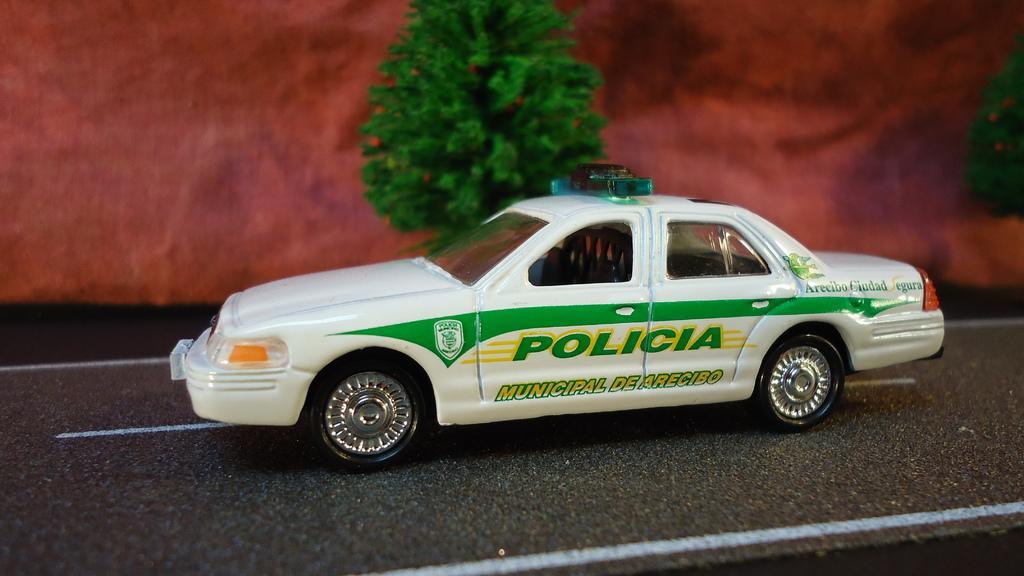In one or two sentences, can you explain what this image depicts? We can see car on the road and we can see trees. In the background it is maroon color. 